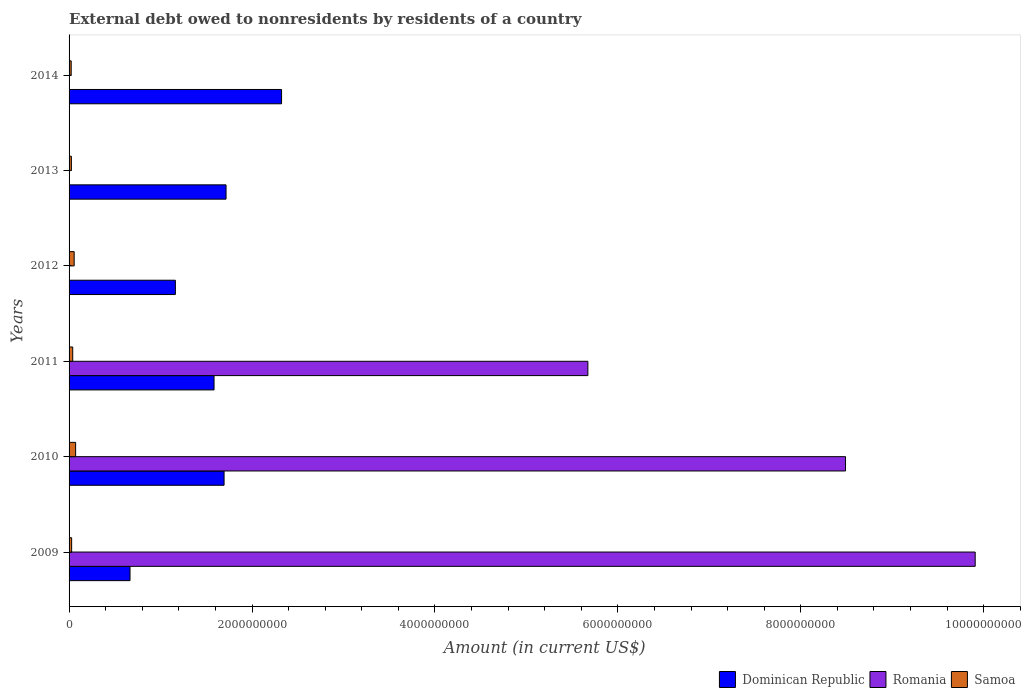How many different coloured bars are there?
Your answer should be compact. 3. How many groups of bars are there?
Your response must be concise. 6. Are the number of bars per tick equal to the number of legend labels?
Your answer should be compact. No. Are the number of bars on each tick of the Y-axis equal?
Give a very brief answer. No. What is the external debt owed by residents in Samoa in 2012?
Provide a short and direct response. 5.57e+07. Across all years, what is the maximum external debt owed by residents in Dominican Republic?
Ensure brevity in your answer.  2.32e+09. Across all years, what is the minimum external debt owed by residents in Samoa?
Give a very brief answer. 2.31e+07. What is the total external debt owed by residents in Samoa in the graph?
Keep it short and to the point. 2.44e+08. What is the difference between the external debt owed by residents in Dominican Republic in 2011 and that in 2013?
Keep it short and to the point. -1.31e+08. What is the difference between the external debt owed by residents in Samoa in 2011 and the external debt owed by residents in Romania in 2012?
Keep it short and to the point. 3.98e+07. What is the average external debt owed by residents in Samoa per year?
Give a very brief answer. 4.06e+07. In the year 2009, what is the difference between the external debt owed by residents in Dominican Republic and external debt owed by residents in Romania?
Give a very brief answer. -9.24e+09. In how many years, is the external debt owed by residents in Romania greater than 7200000000 US$?
Provide a short and direct response. 2. What is the ratio of the external debt owed by residents in Dominican Republic in 2009 to that in 2010?
Provide a succinct answer. 0.39. Is the external debt owed by residents in Samoa in 2009 less than that in 2011?
Make the answer very short. Yes. What is the difference between the highest and the second highest external debt owed by residents in Dominican Republic?
Your answer should be compact. 6.07e+08. What is the difference between the highest and the lowest external debt owed by residents in Samoa?
Ensure brevity in your answer.  4.85e+07. Is the sum of the external debt owed by residents in Romania in 2009 and 2011 greater than the maximum external debt owed by residents in Samoa across all years?
Give a very brief answer. Yes. Is it the case that in every year, the sum of the external debt owed by residents in Dominican Republic and external debt owed by residents in Samoa is greater than the external debt owed by residents in Romania?
Your answer should be very brief. No. How many bars are there?
Offer a very short reply. 15. Are all the bars in the graph horizontal?
Provide a succinct answer. Yes. How many years are there in the graph?
Offer a very short reply. 6. What is the difference between two consecutive major ticks on the X-axis?
Give a very brief answer. 2.00e+09. Are the values on the major ticks of X-axis written in scientific E-notation?
Your answer should be very brief. No. Does the graph contain any zero values?
Your response must be concise. Yes. Does the graph contain grids?
Your answer should be compact. No. Where does the legend appear in the graph?
Ensure brevity in your answer.  Bottom right. What is the title of the graph?
Ensure brevity in your answer.  External debt owed to nonresidents by residents of a country. What is the Amount (in current US$) in Dominican Republic in 2009?
Your response must be concise. 6.66e+08. What is the Amount (in current US$) of Romania in 2009?
Make the answer very short. 9.91e+09. What is the Amount (in current US$) in Samoa in 2009?
Provide a short and direct response. 2.81e+07. What is the Amount (in current US$) in Dominican Republic in 2010?
Offer a very short reply. 1.69e+09. What is the Amount (in current US$) in Romania in 2010?
Keep it short and to the point. 8.49e+09. What is the Amount (in current US$) of Samoa in 2010?
Your answer should be very brief. 7.16e+07. What is the Amount (in current US$) of Dominican Republic in 2011?
Your answer should be compact. 1.59e+09. What is the Amount (in current US$) of Romania in 2011?
Provide a succinct answer. 5.67e+09. What is the Amount (in current US$) of Samoa in 2011?
Your answer should be compact. 3.98e+07. What is the Amount (in current US$) in Dominican Republic in 2012?
Offer a terse response. 1.16e+09. What is the Amount (in current US$) in Samoa in 2012?
Make the answer very short. 5.57e+07. What is the Amount (in current US$) in Dominican Republic in 2013?
Your answer should be compact. 1.72e+09. What is the Amount (in current US$) in Romania in 2013?
Keep it short and to the point. 0. What is the Amount (in current US$) in Samoa in 2013?
Provide a succinct answer. 2.52e+07. What is the Amount (in current US$) of Dominican Republic in 2014?
Ensure brevity in your answer.  2.32e+09. What is the Amount (in current US$) of Romania in 2014?
Give a very brief answer. 0. What is the Amount (in current US$) in Samoa in 2014?
Keep it short and to the point. 2.31e+07. Across all years, what is the maximum Amount (in current US$) in Dominican Republic?
Offer a terse response. 2.32e+09. Across all years, what is the maximum Amount (in current US$) of Romania?
Keep it short and to the point. 9.91e+09. Across all years, what is the maximum Amount (in current US$) of Samoa?
Make the answer very short. 7.16e+07. Across all years, what is the minimum Amount (in current US$) of Dominican Republic?
Make the answer very short. 6.66e+08. Across all years, what is the minimum Amount (in current US$) in Samoa?
Give a very brief answer. 2.31e+07. What is the total Amount (in current US$) in Dominican Republic in the graph?
Make the answer very short. 9.15e+09. What is the total Amount (in current US$) in Romania in the graph?
Keep it short and to the point. 2.41e+1. What is the total Amount (in current US$) of Samoa in the graph?
Offer a terse response. 2.44e+08. What is the difference between the Amount (in current US$) in Dominican Republic in 2009 and that in 2010?
Give a very brief answer. -1.03e+09. What is the difference between the Amount (in current US$) of Romania in 2009 and that in 2010?
Offer a terse response. 1.42e+09. What is the difference between the Amount (in current US$) in Samoa in 2009 and that in 2010?
Keep it short and to the point. -4.35e+07. What is the difference between the Amount (in current US$) in Dominican Republic in 2009 and that in 2011?
Provide a short and direct response. -9.19e+08. What is the difference between the Amount (in current US$) in Romania in 2009 and that in 2011?
Your response must be concise. 4.23e+09. What is the difference between the Amount (in current US$) of Samoa in 2009 and that in 2011?
Your answer should be compact. -1.17e+07. What is the difference between the Amount (in current US$) of Dominican Republic in 2009 and that in 2012?
Your response must be concise. -4.96e+08. What is the difference between the Amount (in current US$) in Samoa in 2009 and that in 2012?
Your response must be concise. -2.76e+07. What is the difference between the Amount (in current US$) in Dominican Republic in 2009 and that in 2013?
Your response must be concise. -1.05e+09. What is the difference between the Amount (in current US$) in Samoa in 2009 and that in 2013?
Give a very brief answer. 2.98e+06. What is the difference between the Amount (in current US$) of Dominican Republic in 2009 and that in 2014?
Ensure brevity in your answer.  -1.66e+09. What is the difference between the Amount (in current US$) of Samoa in 2009 and that in 2014?
Ensure brevity in your answer.  5.01e+06. What is the difference between the Amount (in current US$) of Dominican Republic in 2010 and that in 2011?
Offer a terse response. 1.10e+08. What is the difference between the Amount (in current US$) in Romania in 2010 and that in 2011?
Offer a very short reply. 2.82e+09. What is the difference between the Amount (in current US$) in Samoa in 2010 and that in 2011?
Keep it short and to the point. 3.18e+07. What is the difference between the Amount (in current US$) of Dominican Republic in 2010 and that in 2012?
Your response must be concise. 5.32e+08. What is the difference between the Amount (in current US$) of Samoa in 2010 and that in 2012?
Make the answer very short. 1.59e+07. What is the difference between the Amount (in current US$) of Dominican Republic in 2010 and that in 2013?
Provide a short and direct response. -2.16e+07. What is the difference between the Amount (in current US$) of Samoa in 2010 and that in 2013?
Your answer should be compact. 4.64e+07. What is the difference between the Amount (in current US$) of Dominican Republic in 2010 and that in 2014?
Your answer should be compact. -6.29e+08. What is the difference between the Amount (in current US$) in Samoa in 2010 and that in 2014?
Make the answer very short. 4.85e+07. What is the difference between the Amount (in current US$) in Dominican Republic in 2011 and that in 2012?
Your response must be concise. 4.23e+08. What is the difference between the Amount (in current US$) in Samoa in 2011 and that in 2012?
Your response must be concise. -1.59e+07. What is the difference between the Amount (in current US$) in Dominican Republic in 2011 and that in 2013?
Your response must be concise. -1.31e+08. What is the difference between the Amount (in current US$) in Samoa in 2011 and that in 2013?
Provide a succinct answer. 1.46e+07. What is the difference between the Amount (in current US$) in Dominican Republic in 2011 and that in 2014?
Make the answer very short. -7.38e+08. What is the difference between the Amount (in current US$) in Samoa in 2011 and that in 2014?
Make the answer very short. 1.67e+07. What is the difference between the Amount (in current US$) in Dominican Republic in 2012 and that in 2013?
Your answer should be compact. -5.54e+08. What is the difference between the Amount (in current US$) in Samoa in 2012 and that in 2013?
Your response must be concise. 3.05e+07. What is the difference between the Amount (in current US$) in Dominican Republic in 2012 and that in 2014?
Provide a short and direct response. -1.16e+09. What is the difference between the Amount (in current US$) of Samoa in 2012 and that in 2014?
Ensure brevity in your answer.  3.26e+07. What is the difference between the Amount (in current US$) in Dominican Republic in 2013 and that in 2014?
Your answer should be very brief. -6.07e+08. What is the difference between the Amount (in current US$) of Samoa in 2013 and that in 2014?
Make the answer very short. 2.02e+06. What is the difference between the Amount (in current US$) of Dominican Republic in 2009 and the Amount (in current US$) of Romania in 2010?
Your answer should be compact. -7.82e+09. What is the difference between the Amount (in current US$) in Dominican Republic in 2009 and the Amount (in current US$) in Samoa in 2010?
Ensure brevity in your answer.  5.95e+08. What is the difference between the Amount (in current US$) in Romania in 2009 and the Amount (in current US$) in Samoa in 2010?
Offer a very short reply. 9.84e+09. What is the difference between the Amount (in current US$) of Dominican Republic in 2009 and the Amount (in current US$) of Romania in 2011?
Your response must be concise. -5.01e+09. What is the difference between the Amount (in current US$) in Dominican Republic in 2009 and the Amount (in current US$) in Samoa in 2011?
Offer a terse response. 6.26e+08. What is the difference between the Amount (in current US$) in Romania in 2009 and the Amount (in current US$) in Samoa in 2011?
Your answer should be very brief. 9.87e+09. What is the difference between the Amount (in current US$) in Dominican Republic in 2009 and the Amount (in current US$) in Samoa in 2012?
Ensure brevity in your answer.  6.11e+08. What is the difference between the Amount (in current US$) of Romania in 2009 and the Amount (in current US$) of Samoa in 2012?
Your response must be concise. 9.85e+09. What is the difference between the Amount (in current US$) in Dominican Republic in 2009 and the Amount (in current US$) in Samoa in 2013?
Make the answer very short. 6.41e+08. What is the difference between the Amount (in current US$) in Romania in 2009 and the Amount (in current US$) in Samoa in 2013?
Provide a succinct answer. 9.88e+09. What is the difference between the Amount (in current US$) in Dominican Republic in 2009 and the Amount (in current US$) in Samoa in 2014?
Your answer should be very brief. 6.43e+08. What is the difference between the Amount (in current US$) in Romania in 2009 and the Amount (in current US$) in Samoa in 2014?
Give a very brief answer. 9.88e+09. What is the difference between the Amount (in current US$) in Dominican Republic in 2010 and the Amount (in current US$) in Romania in 2011?
Make the answer very short. -3.98e+09. What is the difference between the Amount (in current US$) of Dominican Republic in 2010 and the Amount (in current US$) of Samoa in 2011?
Give a very brief answer. 1.65e+09. What is the difference between the Amount (in current US$) in Romania in 2010 and the Amount (in current US$) in Samoa in 2011?
Provide a short and direct response. 8.45e+09. What is the difference between the Amount (in current US$) in Dominican Republic in 2010 and the Amount (in current US$) in Samoa in 2012?
Your answer should be compact. 1.64e+09. What is the difference between the Amount (in current US$) of Romania in 2010 and the Amount (in current US$) of Samoa in 2012?
Provide a succinct answer. 8.43e+09. What is the difference between the Amount (in current US$) in Dominican Republic in 2010 and the Amount (in current US$) in Samoa in 2013?
Give a very brief answer. 1.67e+09. What is the difference between the Amount (in current US$) in Romania in 2010 and the Amount (in current US$) in Samoa in 2013?
Offer a very short reply. 8.46e+09. What is the difference between the Amount (in current US$) of Dominican Republic in 2010 and the Amount (in current US$) of Samoa in 2014?
Offer a very short reply. 1.67e+09. What is the difference between the Amount (in current US$) in Romania in 2010 and the Amount (in current US$) in Samoa in 2014?
Give a very brief answer. 8.47e+09. What is the difference between the Amount (in current US$) of Dominican Republic in 2011 and the Amount (in current US$) of Samoa in 2012?
Your response must be concise. 1.53e+09. What is the difference between the Amount (in current US$) in Romania in 2011 and the Amount (in current US$) in Samoa in 2012?
Keep it short and to the point. 5.62e+09. What is the difference between the Amount (in current US$) of Dominican Republic in 2011 and the Amount (in current US$) of Samoa in 2013?
Provide a succinct answer. 1.56e+09. What is the difference between the Amount (in current US$) of Romania in 2011 and the Amount (in current US$) of Samoa in 2013?
Your answer should be very brief. 5.65e+09. What is the difference between the Amount (in current US$) of Dominican Republic in 2011 and the Amount (in current US$) of Samoa in 2014?
Your answer should be very brief. 1.56e+09. What is the difference between the Amount (in current US$) in Romania in 2011 and the Amount (in current US$) in Samoa in 2014?
Provide a short and direct response. 5.65e+09. What is the difference between the Amount (in current US$) of Dominican Republic in 2012 and the Amount (in current US$) of Samoa in 2013?
Your answer should be compact. 1.14e+09. What is the difference between the Amount (in current US$) in Dominican Republic in 2012 and the Amount (in current US$) in Samoa in 2014?
Offer a terse response. 1.14e+09. What is the difference between the Amount (in current US$) in Dominican Republic in 2013 and the Amount (in current US$) in Samoa in 2014?
Offer a very short reply. 1.69e+09. What is the average Amount (in current US$) of Dominican Republic per year?
Keep it short and to the point. 1.52e+09. What is the average Amount (in current US$) of Romania per year?
Make the answer very short. 4.01e+09. What is the average Amount (in current US$) of Samoa per year?
Keep it short and to the point. 4.06e+07. In the year 2009, what is the difference between the Amount (in current US$) in Dominican Republic and Amount (in current US$) in Romania?
Offer a very short reply. -9.24e+09. In the year 2009, what is the difference between the Amount (in current US$) in Dominican Republic and Amount (in current US$) in Samoa?
Keep it short and to the point. 6.38e+08. In the year 2009, what is the difference between the Amount (in current US$) of Romania and Amount (in current US$) of Samoa?
Your answer should be compact. 9.88e+09. In the year 2010, what is the difference between the Amount (in current US$) in Dominican Republic and Amount (in current US$) in Romania?
Offer a very short reply. -6.79e+09. In the year 2010, what is the difference between the Amount (in current US$) of Dominican Republic and Amount (in current US$) of Samoa?
Offer a very short reply. 1.62e+09. In the year 2010, what is the difference between the Amount (in current US$) in Romania and Amount (in current US$) in Samoa?
Your answer should be very brief. 8.42e+09. In the year 2011, what is the difference between the Amount (in current US$) of Dominican Republic and Amount (in current US$) of Romania?
Your response must be concise. -4.09e+09. In the year 2011, what is the difference between the Amount (in current US$) in Dominican Republic and Amount (in current US$) in Samoa?
Offer a very short reply. 1.55e+09. In the year 2011, what is the difference between the Amount (in current US$) in Romania and Amount (in current US$) in Samoa?
Provide a short and direct response. 5.63e+09. In the year 2012, what is the difference between the Amount (in current US$) in Dominican Republic and Amount (in current US$) in Samoa?
Provide a succinct answer. 1.11e+09. In the year 2013, what is the difference between the Amount (in current US$) of Dominican Republic and Amount (in current US$) of Samoa?
Offer a terse response. 1.69e+09. In the year 2014, what is the difference between the Amount (in current US$) in Dominican Republic and Amount (in current US$) in Samoa?
Offer a very short reply. 2.30e+09. What is the ratio of the Amount (in current US$) in Dominican Republic in 2009 to that in 2010?
Ensure brevity in your answer.  0.39. What is the ratio of the Amount (in current US$) in Romania in 2009 to that in 2010?
Ensure brevity in your answer.  1.17. What is the ratio of the Amount (in current US$) in Samoa in 2009 to that in 2010?
Provide a succinct answer. 0.39. What is the ratio of the Amount (in current US$) in Dominican Republic in 2009 to that in 2011?
Your response must be concise. 0.42. What is the ratio of the Amount (in current US$) in Romania in 2009 to that in 2011?
Provide a succinct answer. 1.75. What is the ratio of the Amount (in current US$) in Samoa in 2009 to that in 2011?
Offer a very short reply. 0.71. What is the ratio of the Amount (in current US$) in Dominican Republic in 2009 to that in 2012?
Your response must be concise. 0.57. What is the ratio of the Amount (in current US$) in Samoa in 2009 to that in 2012?
Keep it short and to the point. 0.51. What is the ratio of the Amount (in current US$) in Dominican Republic in 2009 to that in 2013?
Ensure brevity in your answer.  0.39. What is the ratio of the Amount (in current US$) in Samoa in 2009 to that in 2013?
Offer a terse response. 1.12. What is the ratio of the Amount (in current US$) in Dominican Republic in 2009 to that in 2014?
Offer a very short reply. 0.29. What is the ratio of the Amount (in current US$) in Samoa in 2009 to that in 2014?
Offer a very short reply. 1.22. What is the ratio of the Amount (in current US$) of Dominican Republic in 2010 to that in 2011?
Your answer should be compact. 1.07. What is the ratio of the Amount (in current US$) in Romania in 2010 to that in 2011?
Provide a short and direct response. 1.5. What is the ratio of the Amount (in current US$) in Samoa in 2010 to that in 2011?
Your response must be concise. 1.8. What is the ratio of the Amount (in current US$) of Dominican Republic in 2010 to that in 2012?
Your response must be concise. 1.46. What is the ratio of the Amount (in current US$) of Samoa in 2010 to that in 2012?
Give a very brief answer. 1.29. What is the ratio of the Amount (in current US$) in Dominican Republic in 2010 to that in 2013?
Your answer should be compact. 0.99. What is the ratio of the Amount (in current US$) in Samoa in 2010 to that in 2013?
Offer a very short reply. 2.85. What is the ratio of the Amount (in current US$) of Dominican Republic in 2010 to that in 2014?
Provide a short and direct response. 0.73. What is the ratio of the Amount (in current US$) in Samoa in 2010 to that in 2014?
Ensure brevity in your answer.  3.09. What is the ratio of the Amount (in current US$) of Dominican Republic in 2011 to that in 2012?
Offer a very short reply. 1.36. What is the ratio of the Amount (in current US$) in Samoa in 2011 to that in 2012?
Ensure brevity in your answer.  0.71. What is the ratio of the Amount (in current US$) of Dominican Republic in 2011 to that in 2013?
Your answer should be very brief. 0.92. What is the ratio of the Amount (in current US$) in Samoa in 2011 to that in 2013?
Your answer should be very brief. 1.58. What is the ratio of the Amount (in current US$) in Dominican Republic in 2011 to that in 2014?
Offer a terse response. 0.68. What is the ratio of the Amount (in current US$) of Samoa in 2011 to that in 2014?
Your answer should be very brief. 1.72. What is the ratio of the Amount (in current US$) in Dominican Republic in 2012 to that in 2013?
Offer a terse response. 0.68. What is the ratio of the Amount (in current US$) in Samoa in 2012 to that in 2013?
Offer a very short reply. 2.21. What is the ratio of the Amount (in current US$) in Dominican Republic in 2012 to that in 2014?
Your answer should be very brief. 0.5. What is the ratio of the Amount (in current US$) in Samoa in 2012 to that in 2014?
Your answer should be very brief. 2.41. What is the ratio of the Amount (in current US$) in Dominican Republic in 2013 to that in 2014?
Your answer should be very brief. 0.74. What is the ratio of the Amount (in current US$) of Samoa in 2013 to that in 2014?
Your answer should be compact. 1.09. What is the difference between the highest and the second highest Amount (in current US$) of Dominican Republic?
Offer a terse response. 6.07e+08. What is the difference between the highest and the second highest Amount (in current US$) in Romania?
Your answer should be compact. 1.42e+09. What is the difference between the highest and the second highest Amount (in current US$) of Samoa?
Give a very brief answer. 1.59e+07. What is the difference between the highest and the lowest Amount (in current US$) in Dominican Republic?
Your response must be concise. 1.66e+09. What is the difference between the highest and the lowest Amount (in current US$) in Romania?
Provide a succinct answer. 9.91e+09. What is the difference between the highest and the lowest Amount (in current US$) of Samoa?
Offer a very short reply. 4.85e+07. 